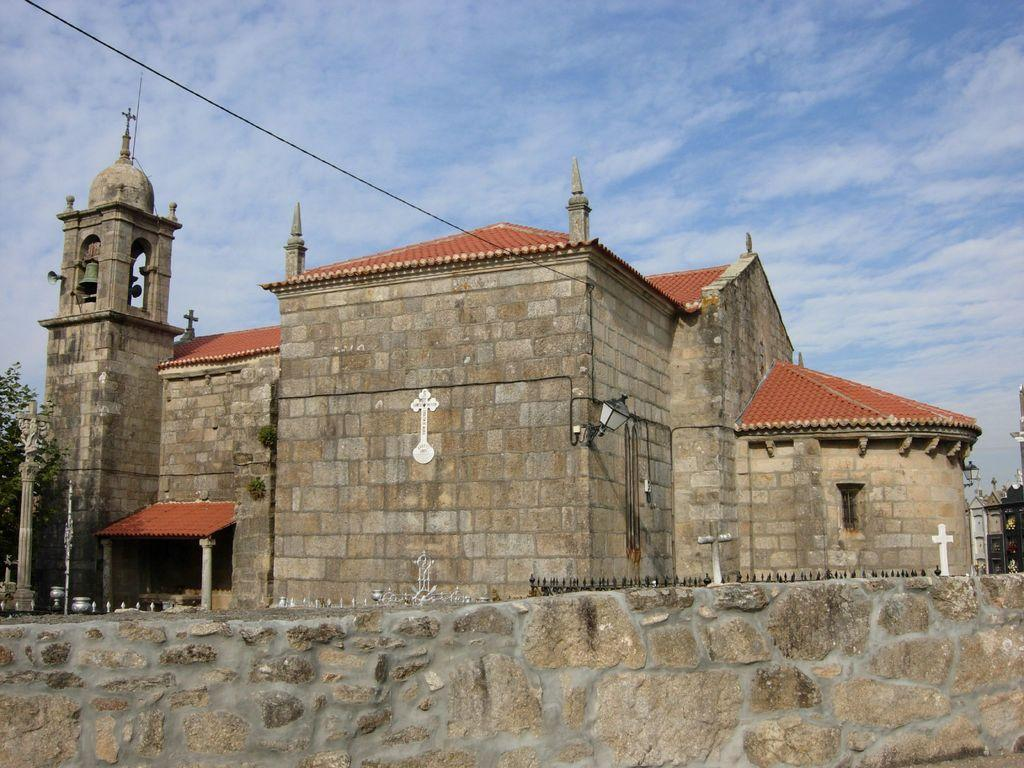What type of structure is visible in the image? There is a building with a roof and stone wall in the image. What is the material of the wall surrounding the building? The wall is made of stone, as indicated by the fact that there is a stone wall in the image. What type of lighting is present in the image? There is a lamp in the image, which suggests that it provides illumination. What type of vegetation is present in the image? There is a tree at the left side of the image. What else can be seen in the image besides the building and tree? There is a wire visible in the image. What is visible at the top of the image? The sky is visible at the top of the image. How many mice are hiding behind the stone wall in the image? There are no mice visible in the image, so it is impossible to determine how many might be hiding behind the stone wall. 